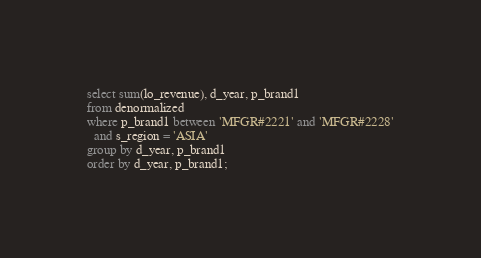<code> <loc_0><loc_0><loc_500><loc_500><_SQL_>select sum(lo_revenue), d_year, p_brand1
from denormalized
where p_brand1 between 'MFGR#2221' and 'MFGR#2228'
  and s_region = 'ASIA'
group by d_year, p_brand1
order by d_year, p_brand1;
</code> 